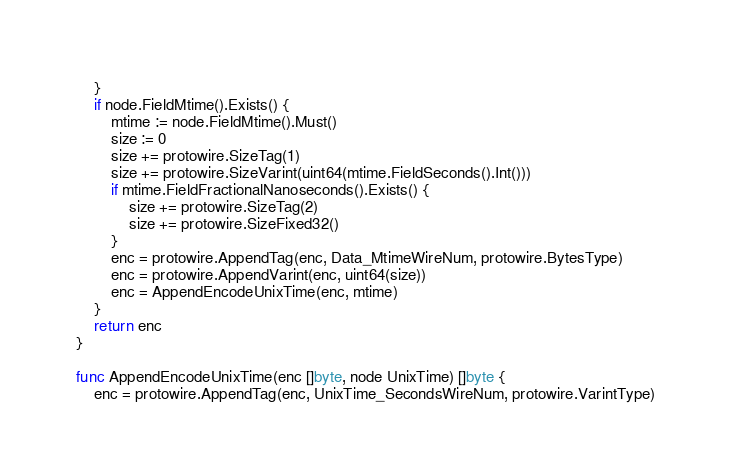Convert code to text. <code><loc_0><loc_0><loc_500><loc_500><_Go_>	}
	if node.FieldMtime().Exists() {
		mtime := node.FieldMtime().Must()
		size := 0
		size += protowire.SizeTag(1)
		size += protowire.SizeVarint(uint64(mtime.FieldSeconds().Int()))
		if mtime.FieldFractionalNanoseconds().Exists() {
			size += protowire.SizeTag(2)
			size += protowire.SizeFixed32()
		}
		enc = protowire.AppendTag(enc, Data_MtimeWireNum, protowire.BytesType)
		enc = protowire.AppendVarint(enc, uint64(size))
		enc = AppendEncodeUnixTime(enc, mtime)
	}
	return enc
}

func AppendEncodeUnixTime(enc []byte, node UnixTime) []byte {
	enc = protowire.AppendTag(enc, UnixTime_SecondsWireNum, protowire.VarintType)</code> 